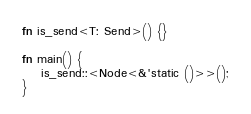<code> <loc_0><loc_0><loc_500><loc_500><_Rust_>
fn is_send<T: Send>() {}

fn main() {
    is_send::<Node<&'static ()>>();
}
</code> 